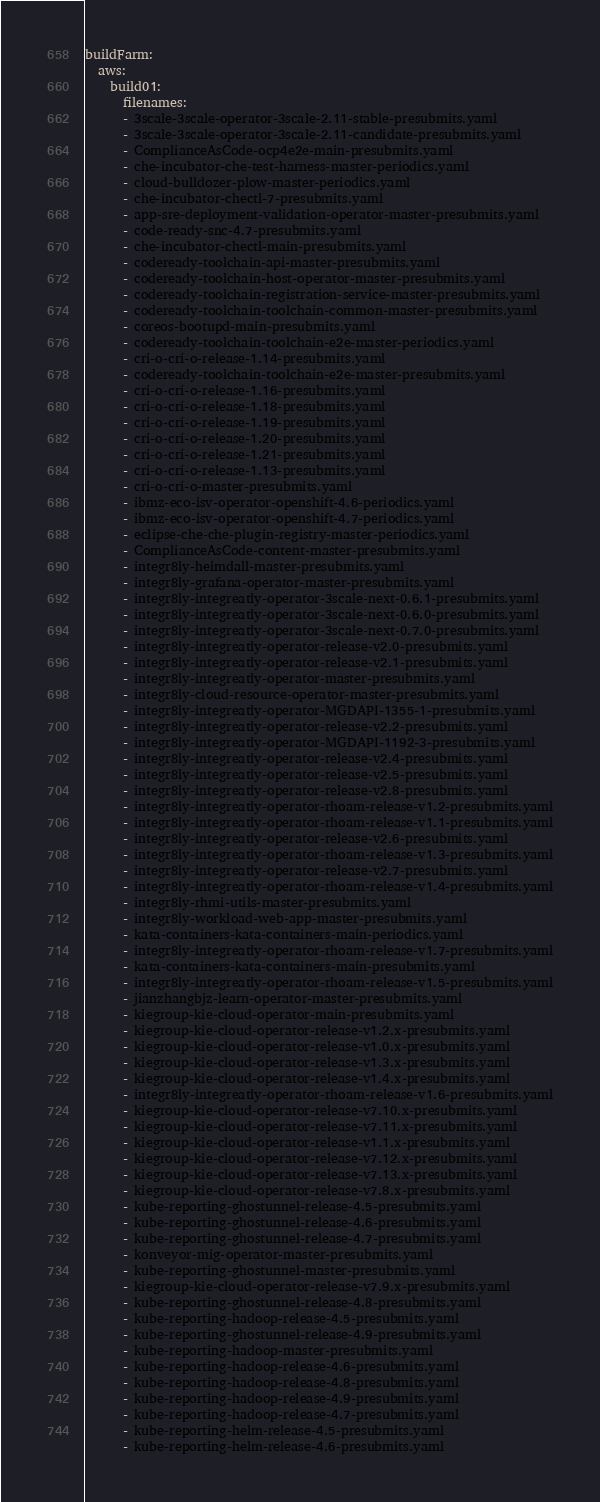Convert code to text. <code><loc_0><loc_0><loc_500><loc_500><_YAML_>buildFarm:
  aws:
    build01:
      filenames:
      - 3scale-3scale-operator-3scale-2.11-stable-presubmits.yaml
      - 3scale-3scale-operator-3scale-2.11-candidate-presubmits.yaml
      - ComplianceAsCode-ocp4e2e-main-presubmits.yaml
      - che-incubator-che-test-harness-master-periodics.yaml
      - cloud-bulldozer-plow-master-periodics.yaml
      - che-incubator-chectl-7-presubmits.yaml
      - app-sre-deployment-validation-operator-master-presubmits.yaml
      - code-ready-snc-4.7-presubmits.yaml
      - che-incubator-chectl-main-presubmits.yaml
      - codeready-toolchain-api-master-presubmits.yaml
      - codeready-toolchain-host-operator-master-presubmits.yaml
      - codeready-toolchain-registration-service-master-presubmits.yaml
      - codeready-toolchain-toolchain-common-master-presubmits.yaml
      - coreos-bootupd-main-presubmits.yaml
      - codeready-toolchain-toolchain-e2e-master-periodics.yaml
      - cri-o-cri-o-release-1.14-presubmits.yaml
      - codeready-toolchain-toolchain-e2e-master-presubmits.yaml
      - cri-o-cri-o-release-1.16-presubmits.yaml
      - cri-o-cri-o-release-1.18-presubmits.yaml
      - cri-o-cri-o-release-1.19-presubmits.yaml
      - cri-o-cri-o-release-1.20-presubmits.yaml
      - cri-o-cri-o-release-1.21-presubmits.yaml
      - cri-o-cri-o-release-1.13-presubmits.yaml
      - cri-o-cri-o-master-presubmits.yaml
      - ibmz-eco-isv-operator-openshift-4.6-periodics.yaml
      - ibmz-eco-isv-operator-openshift-4.7-periodics.yaml
      - eclipse-che-che-plugin-registry-master-periodics.yaml
      - ComplianceAsCode-content-master-presubmits.yaml
      - integr8ly-heimdall-master-presubmits.yaml
      - integr8ly-grafana-operator-master-presubmits.yaml
      - integr8ly-integreatly-operator-3scale-next-0.6.1-presubmits.yaml
      - integr8ly-integreatly-operator-3scale-next-0.6.0-presubmits.yaml
      - integr8ly-integreatly-operator-3scale-next-0.7.0-presubmits.yaml
      - integr8ly-integreatly-operator-release-v2.0-presubmits.yaml
      - integr8ly-integreatly-operator-release-v2.1-presubmits.yaml
      - integr8ly-integreatly-operator-master-presubmits.yaml
      - integr8ly-cloud-resource-operator-master-presubmits.yaml
      - integr8ly-integreatly-operator-MGDAPI-1355-1-presubmits.yaml
      - integr8ly-integreatly-operator-release-v2.2-presubmits.yaml
      - integr8ly-integreatly-operator-MGDAPI-1192-3-presubmits.yaml
      - integr8ly-integreatly-operator-release-v2.4-presubmits.yaml
      - integr8ly-integreatly-operator-release-v2.5-presubmits.yaml
      - integr8ly-integreatly-operator-release-v2.8-presubmits.yaml
      - integr8ly-integreatly-operator-rhoam-release-v1.2-presubmits.yaml
      - integr8ly-integreatly-operator-rhoam-release-v1.1-presubmits.yaml
      - integr8ly-integreatly-operator-release-v2.6-presubmits.yaml
      - integr8ly-integreatly-operator-rhoam-release-v1.3-presubmits.yaml
      - integr8ly-integreatly-operator-release-v2.7-presubmits.yaml
      - integr8ly-integreatly-operator-rhoam-release-v1.4-presubmits.yaml
      - integr8ly-rhmi-utils-master-presubmits.yaml
      - integr8ly-workload-web-app-master-presubmits.yaml
      - kata-containers-kata-containers-main-periodics.yaml
      - integr8ly-integreatly-operator-rhoam-release-v1.7-presubmits.yaml
      - kata-containers-kata-containers-main-presubmits.yaml
      - integr8ly-integreatly-operator-rhoam-release-v1.5-presubmits.yaml
      - jianzhangbjz-learn-operator-master-presubmits.yaml
      - kiegroup-kie-cloud-operator-main-presubmits.yaml
      - kiegroup-kie-cloud-operator-release-v1.2.x-presubmits.yaml
      - kiegroup-kie-cloud-operator-release-v1.0.x-presubmits.yaml
      - kiegroup-kie-cloud-operator-release-v1.3.x-presubmits.yaml
      - kiegroup-kie-cloud-operator-release-v1.4.x-presubmits.yaml
      - integr8ly-integreatly-operator-rhoam-release-v1.6-presubmits.yaml
      - kiegroup-kie-cloud-operator-release-v7.10.x-presubmits.yaml
      - kiegroup-kie-cloud-operator-release-v7.11.x-presubmits.yaml
      - kiegroup-kie-cloud-operator-release-v1.1.x-presubmits.yaml
      - kiegroup-kie-cloud-operator-release-v7.12.x-presubmits.yaml
      - kiegroup-kie-cloud-operator-release-v7.13.x-presubmits.yaml
      - kiegroup-kie-cloud-operator-release-v7.8.x-presubmits.yaml
      - kube-reporting-ghostunnel-release-4.5-presubmits.yaml
      - kube-reporting-ghostunnel-release-4.6-presubmits.yaml
      - kube-reporting-ghostunnel-release-4.7-presubmits.yaml
      - konveyor-mig-operator-master-presubmits.yaml
      - kube-reporting-ghostunnel-master-presubmits.yaml
      - kiegroup-kie-cloud-operator-release-v7.9.x-presubmits.yaml
      - kube-reporting-ghostunnel-release-4.8-presubmits.yaml
      - kube-reporting-hadoop-release-4.5-presubmits.yaml
      - kube-reporting-ghostunnel-release-4.9-presubmits.yaml
      - kube-reporting-hadoop-master-presubmits.yaml
      - kube-reporting-hadoop-release-4.6-presubmits.yaml
      - kube-reporting-hadoop-release-4.8-presubmits.yaml
      - kube-reporting-hadoop-release-4.9-presubmits.yaml
      - kube-reporting-hadoop-release-4.7-presubmits.yaml
      - kube-reporting-helm-release-4.5-presubmits.yaml
      - kube-reporting-helm-release-4.6-presubmits.yaml</code> 